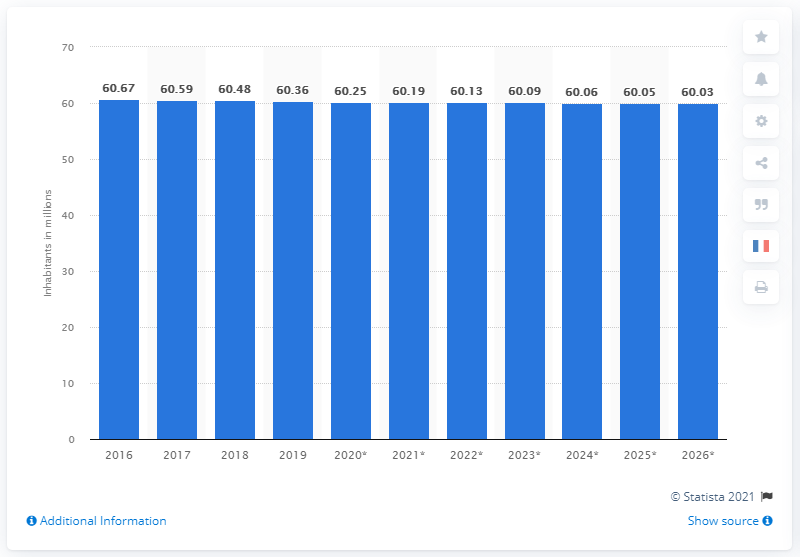Give some essential details in this illustration. As of 2019, the estimated population of Italy was 60,030,000 people. 